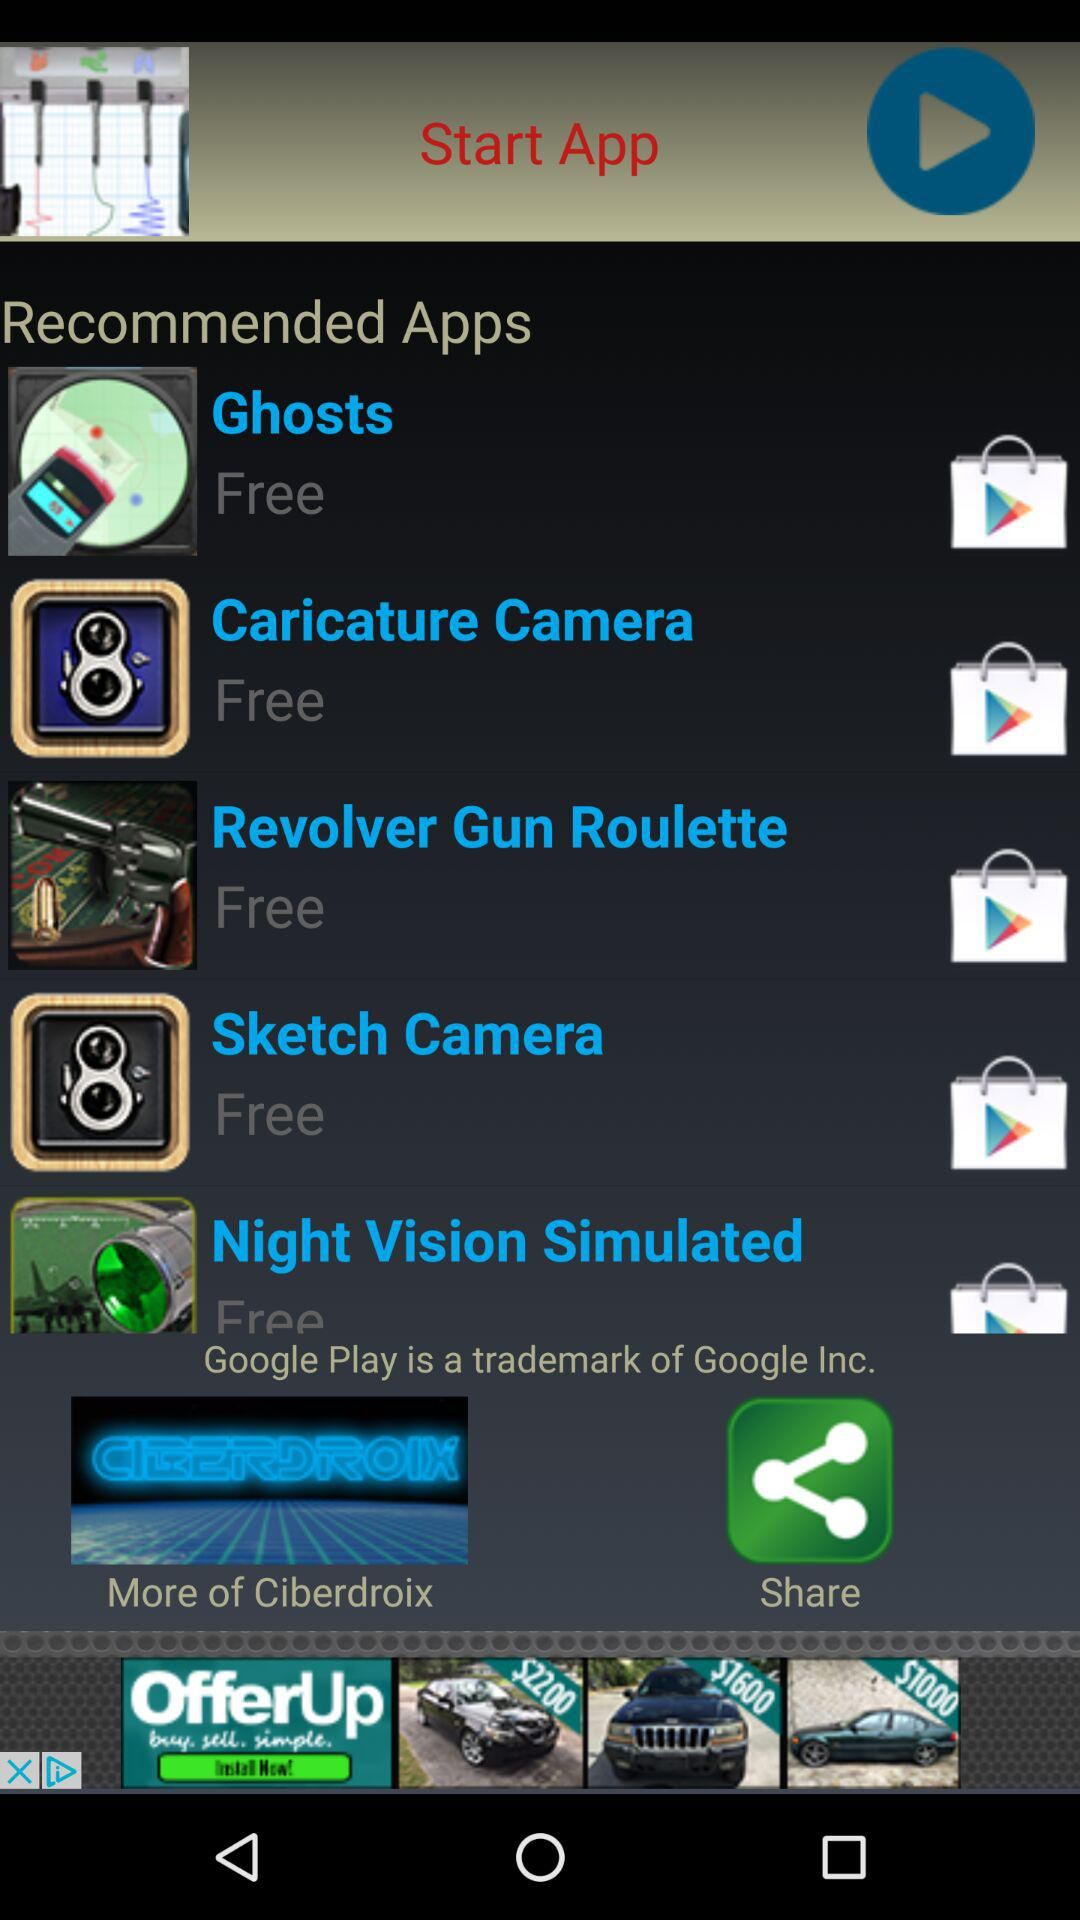Which company's trademark is "Google Play"? "Google Play" is the trademark of "Google Inc.". 